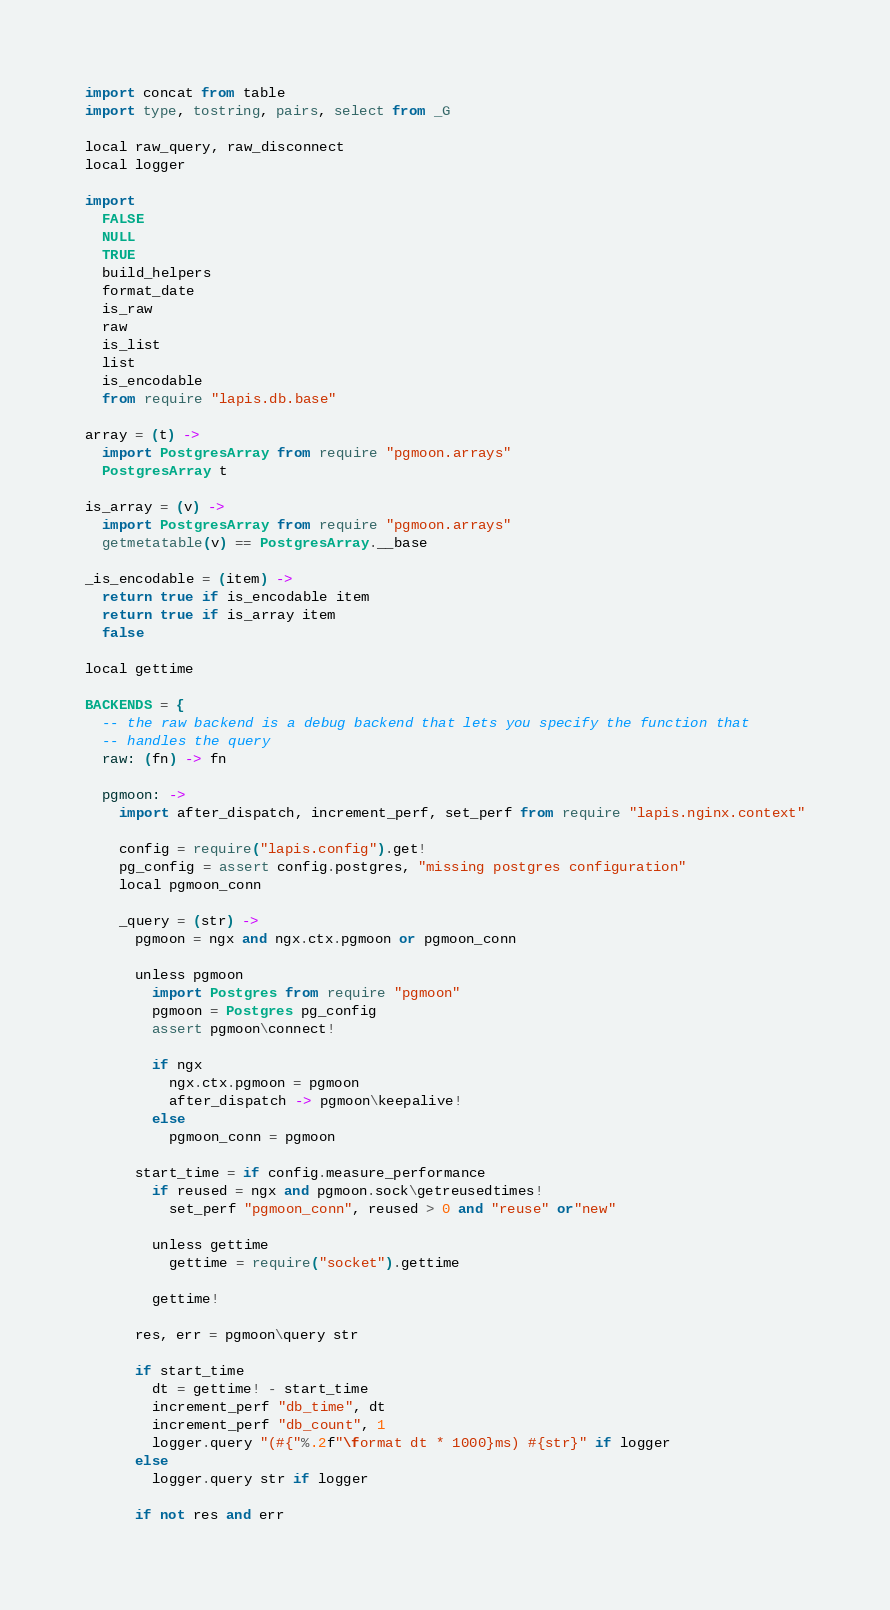<code> <loc_0><loc_0><loc_500><loc_500><_MoonScript_>import concat from table
import type, tostring, pairs, select from _G

local raw_query, raw_disconnect
local logger

import
  FALSE
  NULL
  TRUE
  build_helpers
  format_date
  is_raw
  raw
  is_list
  list
  is_encodable
  from require "lapis.db.base"

array = (t) ->
  import PostgresArray from require "pgmoon.arrays"
  PostgresArray t

is_array = (v) ->
  import PostgresArray from require "pgmoon.arrays"
  getmetatable(v) == PostgresArray.__base

_is_encodable = (item) ->
  return true if is_encodable item
  return true if is_array item
  false

local gettime

BACKENDS = {
  -- the raw backend is a debug backend that lets you specify the function that
  -- handles the query
  raw: (fn) -> fn

  pgmoon: ->
    import after_dispatch, increment_perf, set_perf from require "lapis.nginx.context"

    config = require("lapis.config").get!
    pg_config = assert config.postgres, "missing postgres configuration"
    local pgmoon_conn

    _query = (str) ->
      pgmoon = ngx and ngx.ctx.pgmoon or pgmoon_conn

      unless pgmoon
        import Postgres from require "pgmoon"
        pgmoon = Postgres pg_config
        assert pgmoon\connect!

        if ngx
          ngx.ctx.pgmoon = pgmoon
          after_dispatch -> pgmoon\keepalive!
        else
          pgmoon_conn = pgmoon

      start_time = if config.measure_performance
        if reused = ngx and pgmoon.sock\getreusedtimes!
          set_perf "pgmoon_conn", reused > 0 and "reuse" or"new"

        unless gettime
          gettime = require("socket").gettime

        gettime!

      res, err = pgmoon\query str

      if start_time
        dt = gettime! - start_time
        increment_perf "db_time", dt
        increment_perf "db_count", 1
        logger.query "(#{"%.2f"\format dt * 1000}ms) #{str}" if logger
      else
        logger.query str if logger

      if not res and err</code> 